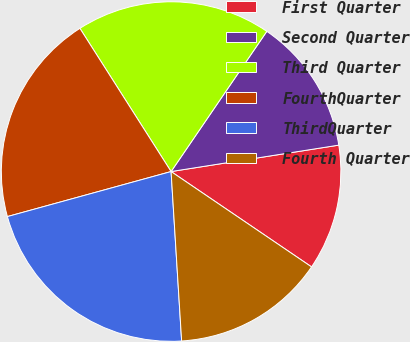Convert chart to OTSL. <chart><loc_0><loc_0><loc_500><loc_500><pie_chart><fcel>First Quarter<fcel>Second Quarter<fcel>Third Quarter<fcel>FourthQuarter<fcel>ThirdQuarter<fcel>Fourth Quarter<nl><fcel>11.98%<fcel>12.98%<fcel>18.56%<fcel>20.25%<fcel>21.72%<fcel>14.52%<nl></chart> 